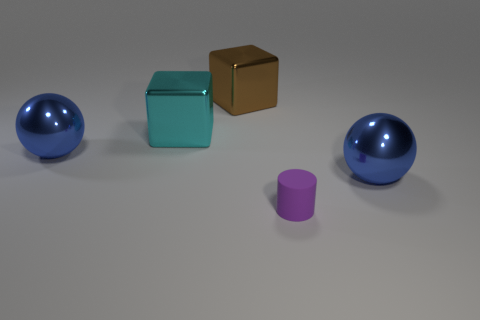Is there a large cyan thing in front of the large metal thing that is on the left side of the large block left of the brown metallic block?
Make the answer very short. No. What shape is the brown thing that is the same size as the cyan metal object?
Your response must be concise. Cube. Is there a big metal thing of the same color as the small object?
Your answer should be compact. No. Is the cyan thing the same shape as the big brown metallic object?
Provide a short and direct response. Yes. What number of small things are cyan rubber cubes or blocks?
Offer a very short reply. 0. The other block that is the same material as the brown cube is what color?
Give a very brief answer. Cyan. What number of brown objects are the same material as the small purple object?
Offer a terse response. 0. There is a blue sphere on the right side of the small purple matte cylinder; is it the same size as the blue metal ball that is on the left side of the tiny purple cylinder?
Give a very brief answer. Yes. There is a big thing in front of the blue sphere on the left side of the tiny cylinder; what is it made of?
Give a very brief answer. Metal. Are there fewer purple objects in front of the small matte object than purple rubber cylinders that are behind the big brown block?
Offer a very short reply. No. 